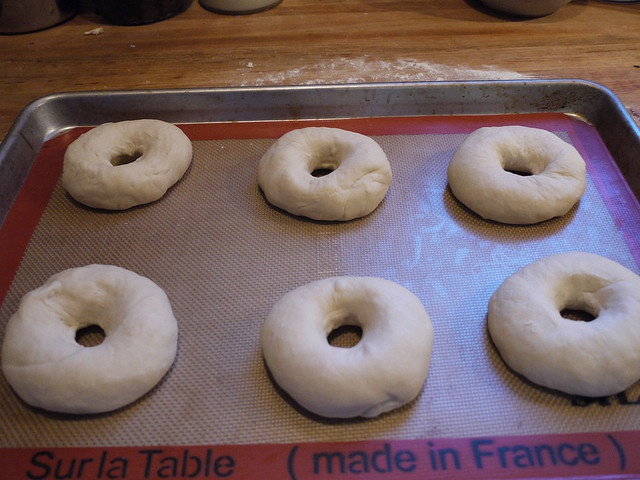Describe the objects in this image and their specific colors. I can see dining table in gray, darkgray, maroon, and black tones, donut in black, darkgray, and gray tones, donut in black, darkgray, and gray tones, donut in black, darkgray, and gray tones, and donut in black, darkgray, and gray tones in this image. 